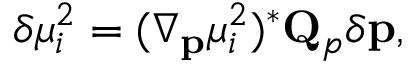<formula> <loc_0><loc_0><loc_500><loc_500>\delta \mu _ { i } ^ { 2 } = ( \nabla _ { p } \mu _ { i } ^ { 2 } ) ^ { * } Q _ { p } \delta p ,</formula> 